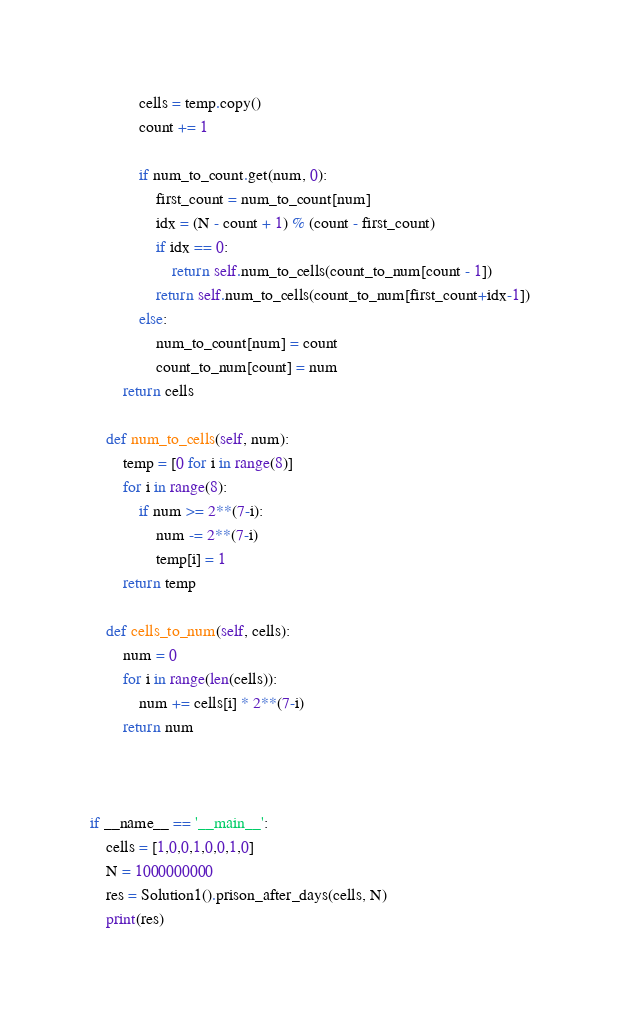Convert code to text. <code><loc_0><loc_0><loc_500><loc_500><_Python_>            cells = temp.copy()
            count += 1

            if num_to_count.get(num, 0):
                first_count = num_to_count[num]
                idx = (N - count + 1) % (count - first_count)
                if idx == 0:
                    return self.num_to_cells(count_to_num[count - 1])
                return self.num_to_cells(count_to_num[first_count+idx-1])
            else:
                num_to_count[num] = count
                count_to_num[count] = num
        return cells

    def num_to_cells(self, num):
        temp = [0 for i in range(8)]
        for i in range(8):
            if num >= 2**(7-i):
                num -= 2**(7-i)
                temp[i] = 1
        return temp

    def cells_to_num(self, cells):
        num = 0
        for i in range(len(cells)):
            num += cells[i] * 2**(7-i)
        return num

        

if __name__ == '__main__':
    cells = [1,0,0,1,0,0,1,0]
    N = 1000000000
    res = Solution1().prison_after_days(cells, N)
    print(res)</code> 